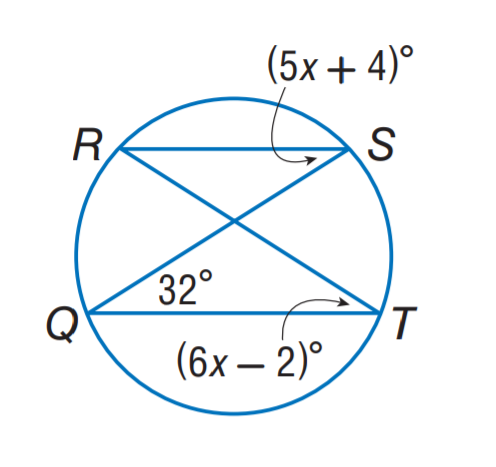Answer the mathemtical geometry problem and directly provide the correct option letter.
Question: Find m \angle R.
Choices: A: 28 B: 30 C: 32 D: 34 C 